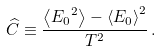<formula> <loc_0><loc_0><loc_500><loc_500>\widehat { C } \equiv \frac { \left \langle { E _ { 0 } } ^ { 2 } \right \rangle - \left \langle E _ { 0 } \right \rangle ^ { 2 } } { T ^ { 2 } } \, .</formula> 